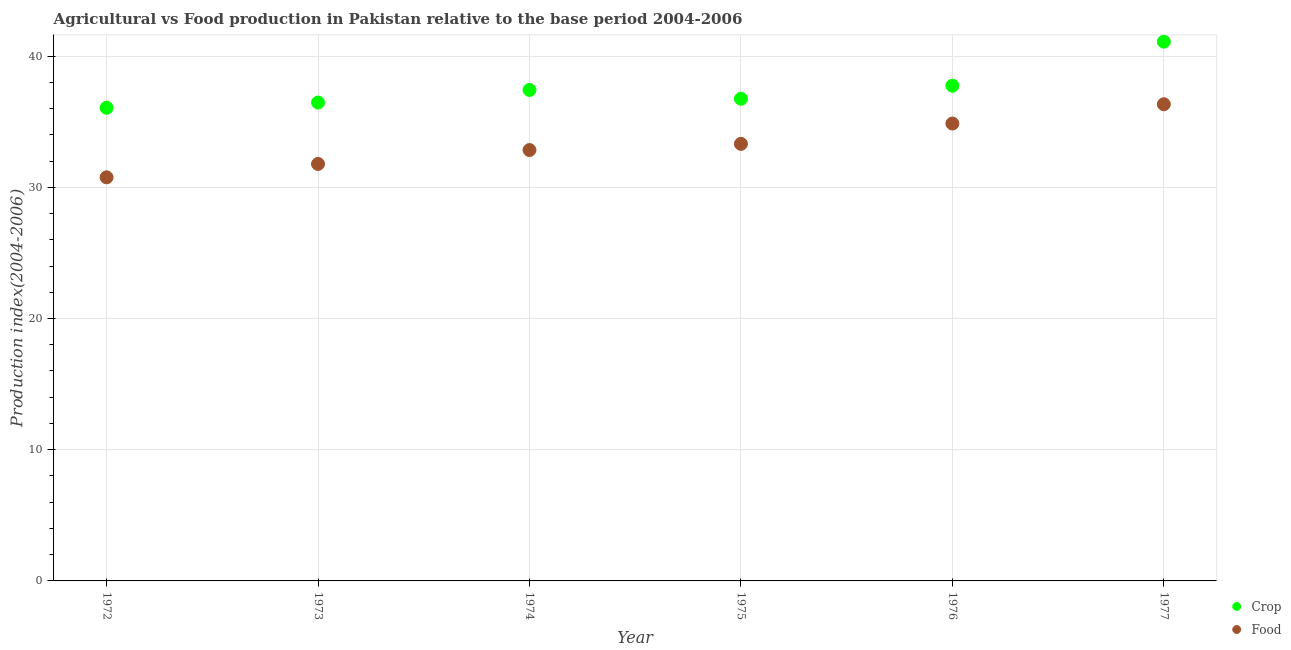Is the number of dotlines equal to the number of legend labels?
Provide a short and direct response. Yes. What is the food production index in 1973?
Keep it short and to the point. 31.78. Across all years, what is the maximum food production index?
Your answer should be compact. 36.33. Across all years, what is the minimum crop production index?
Keep it short and to the point. 36.06. What is the total food production index in the graph?
Offer a very short reply. 199.88. What is the difference between the food production index in 1972 and that in 1976?
Provide a succinct answer. -4.1. What is the difference between the crop production index in 1975 and the food production index in 1973?
Provide a short and direct response. 4.97. What is the average food production index per year?
Your answer should be very brief. 33.31. In the year 1974, what is the difference between the crop production index and food production index?
Give a very brief answer. 4.58. What is the ratio of the crop production index in 1974 to that in 1976?
Your answer should be compact. 0.99. Is the difference between the food production index in 1975 and 1977 greater than the difference between the crop production index in 1975 and 1977?
Provide a succinct answer. Yes. What is the difference between the highest and the second highest food production index?
Your response must be concise. 1.47. What is the difference between the highest and the lowest food production index?
Your answer should be compact. 5.57. In how many years, is the food production index greater than the average food production index taken over all years?
Your answer should be compact. 2. Is the crop production index strictly less than the food production index over the years?
Offer a terse response. No. How many dotlines are there?
Your response must be concise. 2. How many years are there in the graph?
Your response must be concise. 6. Does the graph contain grids?
Your answer should be very brief. Yes. What is the title of the graph?
Provide a short and direct response. Agricultural vs Food production in Pakistan relative to the base period 2004-2006. Does "Health Care" appear as one of the legend labels in the graph?
Provide a short and direct response. No. What is the label or title of the X-axis?
Keep it short and to the point. Year. What is the label or title of the Y-axis?
Make the answer very short. Production index(2004-2006). What is the Production index(2004-2006) in Crop in 1972?
Your answer should be compact. 36.06. What is the Production index(2004-2006) of Food in 1972?
Offer a very short reply. 30.76. What is the Production index(2004-2006) in Crop in 1973?
Ensure brevity in your answer.  36.46. What is the Production index(2004-2006) of Food in 1973?
Offer a terse response. 31.78. What is the Production index(2004-2006) of Crop in 1974?
Your answer should be compact. 37.42. What is the Production index(2004-2006) in Food in 1974?
Your answer should be compact. 32.84. What is the Production index(2004-2006) of Crop in 1975?
Provide a succinct answer. 36.75. What is the Production index(2004-2006) in Food in 1975?
Your response must be concise. 33.31. What is the Production index(2004-2006) in Crop in 1976?
Your answer should be very brief. 37.74. What is the Production index(2004-2006) of Food in 1976?
Keep it short and to the point. 34.86. What is the Production index(2004-2006) of Crop in 1977?
Offer a very short reply. 41.1. What is the Production index(2004-2006) of Food in 1977?
Provide a succinct answer. 36.33. Across all years, what is the maximum Production index(2004-2006) in Crop?
Ensure brevity in your answer.  41.1. Across all years, what is the maximum Production index(2004-2006) in Food?
Offer a very short reply. 36.33. Across all years, what is the minimum Production index(2004-2006) in Crop?
Give a very brief answer. 36.06. Across all years, what is the minimum Production index(2004-2006) of Food?
Give a very brief answer. 30.76. What is the total Production index(2004-2006) of Crop in the graph?
Ensure brevity in your answer.  225.53. What is the total Production index(2004-2006) of Food in the graph?
Offer a terse response. 199.88. What is the difference between the Production index(2004-2006) in Food in 1972 and that in 1973?
Your answer should be very brief. -1.02. What is the difference between the Production index(2004-2006) in Crop in 1972 and that in 1974?
Provide a succinct answer. -1.36. What is the difference between the Production index(2004-2006) in Food in 1972 and that in 1974?
Provide a short and direct response. -2.08. What is the difference between the Production index(2004-2006) of Crop in 1972 and that in 1975?
Give a very brief answer. -0.69. What is the difference between the Production index(2004-2006) in Food in 1972 and that in 1975?
Offer a terse response. -2.55. What is the difference between the Production index(2004-2006) in Crop in 1972 and that in 1976?
Ensure brevity in your answer.  -1.68. What is the difference between the Production index(2004-2006) of Crop in 1972 and that in 1977?
Your response must be concise. -5.04. What is the difference between the Production index(2004-2006) in Food in 1972 and that in 1977?
Ensure brevity in your answer.  -5.57. What is the difference between the Production index(2004-2006) of Crop in 1973 and that in 1974?
Provide a short and direct response. -0.96. What is the difference between the Production index(2004-2006) in Food in 1973 and that in 1974?
Your answer should be compact. -1.06. What is the difference between the Production index(2004-2006) of Crop in 1973 and that in 1975?
Keep it short and to the point. -0.29. What is the difference between the Production index(2004-2006) in Food in 1973 and that in 1975?
Provide a succinct answer. -1.53. What is the difference between the Production index(2004-2006) of Crop in 1973 and that in 1976?
Provide a short and direct response. -1.28. What is the difference between the Production index(2004-2006) in Food in 1973 and that in 1976?
Provide a short and direct response. -3.08. What is the difference between the Production index(2004-2006) of Crop in 1973 and that in 1977?
Your response must be concise. -4.64. What is the difference between the Production index(2004-2006) in Food in 1973 and that in 1977?
Your answer should be compact. -4.55. What is the difference between the Production index(2004-2006) of Crop in 1974 and that in 1975?
Ensure brevity in your answer.  0.67. What is the difference between the Production index(2004-2006) in Food in 1974 and that in 1975?
Provide a short and direct response. -0.47. What is the difference between the Production index(2004-2006) of Crop in 1974 and that in 1976?
Ensure brevity in your answer.  -0.32. What is the difference between the Production index(2004-2006) in Food in 1974 and that in 1976?
Your answer should be very brief. -2.02. What is the difference between the Production index(2004-2006) in Crop in 1974 and that in 1977?
Offer a terse response. -3.68. What is the difference between the Production index(2004-2006) of Food in 1974 and that in 1977?
Your response must be concise. -3.49. What is the difference between the Production index(2004-2006) of Crop in 1975 and that in 1976?
Your response must be concise. -0.99. What is the difference between the Production index(2004-2006) of Food in 1975 and that in 1976?
Your answer should be compact. -1.55. What is the difference between the Production index(2004-2006) in Crop in 1975 and that in 1977?
Provide a short and direct response. -4.35. What is the difference between the Production index(2004-2006) of Food in 1975 and that in 1977?
Make the answer very short. -3.02. What is the difference between the Production index(2004-2006) of Crop in 1976 and that in 1977?
Offer a very short reply. -3.36. What is the difference between the Production index(2004-2006) of Food in 1976 and that in 1977?
Your answer should be very brief. -1.47. What is the difference between the Production index(2004-2006) in Crop in 1972 and the Production index(2004-2006) in Food in 1973?
Offer a very short reply. 4.28. What is the difference between the Production index(2004-2006) in Crop in 1972 and the Production index(2004-2006) in Food in 1974?
Your answer should be very brief. 3.22. What is the difference between the Production index(2004-2006) of Crop in 1972 and the Production index(2004-2006) of Food in 1975?
Your answer should be very brief. 2.75. What is the difference between the Production index(2004-2006) in Crop in 1972 and the Production index(2004-2006) in Food in 1977?
Make the answer very short. -0.27. What is the difference between the Production index(2004-2006) of Crop in 1973 and the Production index(2004-2006) of Food in 1974?
Your answer should be compact. 3.62. What is the difference between the Production index(2004-2006) in Crop in 1973 and the Production index(2004-2006) in Food in 1975?
Provide a short and direct response. 3.15. What is the difference between the Production index(2004-2006) in Crop in 1973 and the Production index(2004-2006) in Food in 1977?
Your answer should be compact. 0.13. What is the difference between the Production index(2004-2006) in Crop in 1974 and the Production index(2004-2006) in Food in 1975?
Offer a very short reply. 4.11. What is the difference between the Production index(2004-2006) in Crop in 1974 and the Production index(2004-2006) in Food in 1976?
Offer a terse response. 2.56. What is the difference between the Production index(2004-2006) in Crop in 1974 and the Production index(2004-2006) in Food in 1977?
Ensure brevity in your answer.  1.09. What is the difference between the Production index(2004-2006) in Crop in 1975 and the Production index(2004-2006) in Food in 1976?
Give a very brief answer. 1.89. What is the difference between the Production index(2004-2006) in Crop in 1975 and the Production index(2004-2006) in Food in 1977?
Your answer should be compact. 0.42. What is the difference between the Production index(2004-2006) in Crop in 1976 and the Production index(2004-2006) in Food in 1977?
Provide a short and direct response. 1.41. What is the average Production index(2004-2006) of Crop per year?
Your answer should be very brief. 37.59. What is the average Production index(2004-2006) of Food per year?
Provide a succinct answer. 33.31. In the year 1973, what is the difference between the Production index(2004-2006) in Crop and Production index(2004-2006) in Food?
Your response must be concise. 4.68. In the year 1974, what is the difference between the Production index(2004-2006) in Crop and Production index(2004-2006) in Food?
Give a very brief answer. 4.58. In the year 1975, what is the difference between the Production index(2004-2006) of Crop and Production index(2004-2006) of Food?
Provide a short and direct response. 3.44. In the year 1976, what is the difference between the Production index(2004-2006) in Crop and Production index(2004-2006) in Food?
Provide a succinct answer. 2.88. In the year 1977, what is the difference between the Production index(2004-2006) of Crop and Production index(2004-2006) of Food?
Make the answer very short. 4.77. What is the ratio of the Production index(2004-2006) in Crop in 1972 to that in 1973?
Your answer should be compact. 0.99. What is the ratio of the Production index(2004-2006) in Food in 1972 to that in 1973?
Offer a very short reply. 0.97. What is the ratio of the Production index(2004-2006) in Crop in 1972 to that in 1974?
Offer a terse response. 0.96. What is the ratio of the Production index(2004-2006) in Food in 1972 to that in 1974?
Offer a terse response. 0.94. What is the ratio of the Production index(2004-2006) in Crop in 1972 to that in 1975?
Provide a succinct answer. 0.98. What is the ratio of the Production index(2004-2006) of Food in 1972 to that in 1975?
Give a very brief answer. 0.92. What is the ratio of the Production index(2004-2006) of Crop in 1972 to that in 1976?
Your answer should be very brief. 0.96. What is the ratio of the Production index(2004-2006) in Food in 1972 to that in 1976?
Offer a very short reply. 0.88. What is the ratio of the Production index(2004-2006) in Crop in 1972 to that in 1977?
Keep it short and to the point. 0.88. What is the ratio of the Production index(2004-2006) of Food in 1972 to that in 1977?
Your answer should be very brief. 0.85. What is the ratio of the Production index(2004-2006) of Crop in 1973 to that in 1974?
Provide a short and direct response. 0.97. What is the ratio of the Production index(2004-2006) of Food in 1973 to that in 1974?
Your response must be concise. 0.97. What is the ratio of the Production index(2004-2006) of Food in 1973 to that in 1975?
Give a very brief answer. 0.95. What is the ratio of the Production index(2004-2006) in Crop in 1973 to that in 1976?
Make the answer very short. 0.97. What is the ratio of the Production index(2004-2006) of Food in 1973 to that in 1976?
Provide a short and direct response. 0.91. What is the ratio of the Production index(2004-2006) of Crop in 1973 to that in 1977?
Provide a succinct answer. 0.89. What is the ratio of the Production index(2004-2006) in Food in 1973 to that in 1977?
Make the answer very short. 0.87. What is the ratio of the Production index(2004-2006) in Crop in 1974 to that in 1975?
Make the answer very short. 1.02. What is the ratio of the Production index(2004-2006) of Food in 1974 to that in 1975?
Your answer should be very brief. 0.99. What is the ratio of the Production index(2004-2006) of Crop in 1974 to that in 1976?
Your response must be concise. 0.99. What is the ratio of the Production index(2004-2006) of Food in 1974 to that in 1976?
Keep it short and to the point. 0.94. What is the ratio of the Production index(2004-2006) in Crop in 1974 to that in 1977?
Ensure brevity in your answer.  0.91. What is the ratio of the Production index(2004-2006) in Food in 1974 to that in 1977?
Give a very brief answer. 0.9. What is the ratio of the Production index(2004-2006) of Crop in 1975 to that in 1976?
Your response must be concise. 0.97. What is the ratio of the Production index(2004-2006) in Food in 1975 to that in 1976?
Your answer should be compact. 0.96. What is the ratio of the Production index(2004-2006) of Crop in 1975 to that in 1977?
Ensure brevity in your answer.  0.89. What is the ratio of the Production index(2004-2006) in Food in 1975 to that in 1977?
Provide a succinct answer. 0.92. What is the ratio of the Production index(2004-2006) in Crop in 1976 to that in 1977?
Give a very brief answer. 0.92. What is the ratio of the Production index(2004-2006) in Food in 1976 to that in 1977?
Offer a very short reply. 0.96. What is the difference between the highest and the second highest Production index(2004-2006) of Crop?
Your answer should be very brief. 3.36. What is the difference between the highest and the second highest Production index(2004-2006) of Food?
Make the answer very short. 1.47. What is the difference between the highest and the lowest Production index(2004-2006) in Crop?
Make the answer very short. 5.04. What is the difference between the highest and the lowest Production index(2004-2006) of Food?
Your response must be concise. 5.57. 